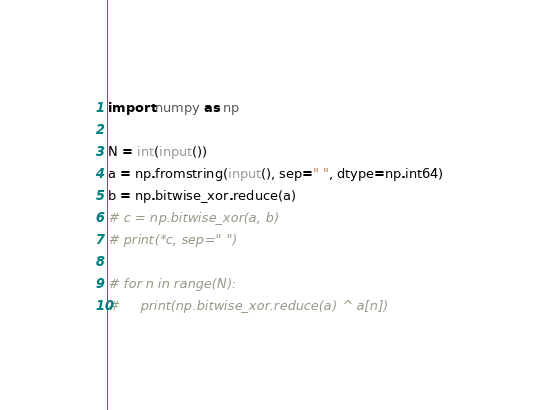<code> <loc_0><loc_0><loc_500><loc_500><_Python_>import numpy as np

N = int(input())
a = np.fromstring(input(), sep=" ", dtype=np.int64)
b = np.bitwise_xor.reduce(a)
# c = np.bitwise_xor(a, b)
# print(*c, sep=" ")

# for n in range(N):
#     print(np.bitwise_xor.reduce(a) ^ a[n])
</code> 